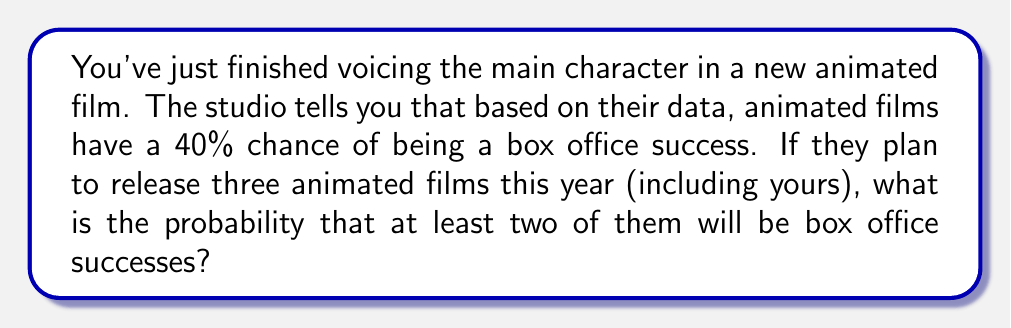Teach me how to tackle this problem. Let's approach this step-by-step:

1) First, we need to recognize that this is a binomial probability problem. We have a fixed number of trials (3 films) and a constant probability of success for each trial (40% or 0.4).

2) We want to find the probability of at least two successes out of three films. This can be calculated by finding the probability of exactly two successes plus the probability of three successes.

3) Let's use the binomial probability formula:

   $P(X = k) = \binom{n}{k} p^k (1-p)^{n-k}$

   Where:
   $n$ = number of trials (3 films)
   $k$ = number of successes
   $p$ = probability of success (0.4)

4) For exactly two successes:
   
   $P(X = 2) = \binom{3}{2} (0.4)^2 (1-0.4)^{3-2}$
   
   $= 3 \cdot 0.16 \cdot 0.6 = 0.288$

5) For exactly three successes:
   
   $P(X = 3) = \binom{3}{3} (0.4)^3 (1-0.4)^{3-3}$
   
   $= 1 \cdot 0.064 \cdot 1 = 0.064$

6) The probability of at least two successes is the sum of these probabilities:

   $P(X \geq 2) = P(X = 2) + P(X = 3) = 0.288 + 0.064 = 0.352$

Therefore, the probability that at least two of the three films will be box office successes is 0.352 or 35.2%.
Answer: 0.352 or 35.2% 